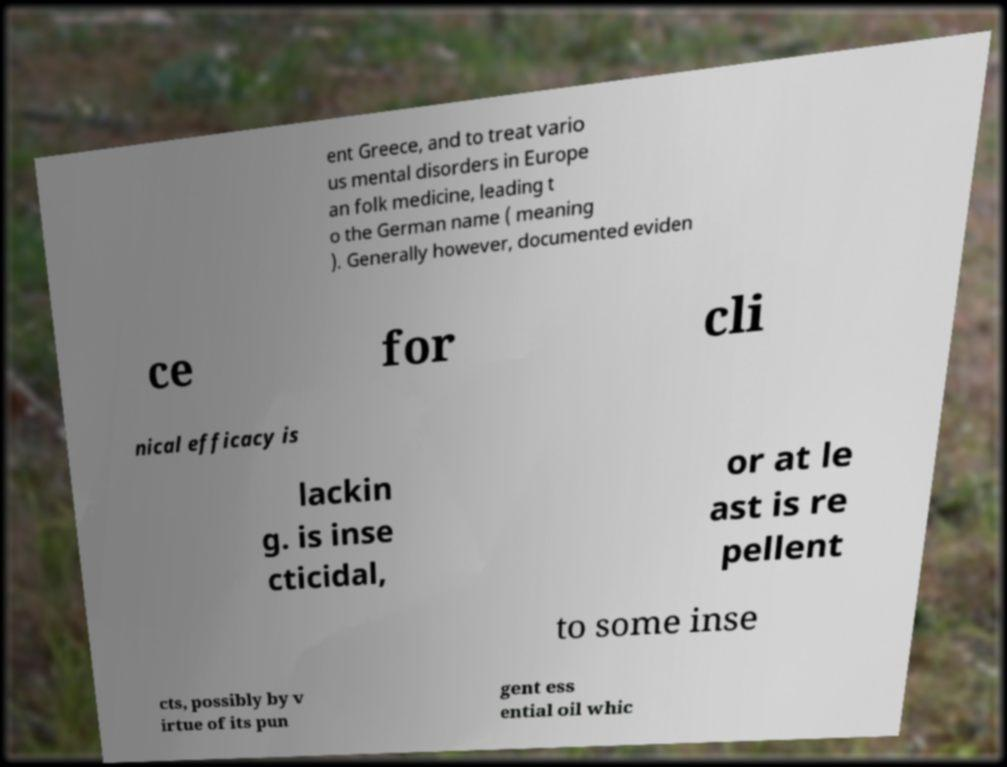Please read and relay the text visible in this image. What does it say? ent Greece, and to treat vario us mental disorders in Europe an folk medicine, leading t o the German name ( meaning ). Generally however, documented eviden ce for cli nical efficacy is lackin g. is inse cticidal, or at le ast is re pellent to some inse cts, possibly by v irtue of its pun gent ess ential oil whic 